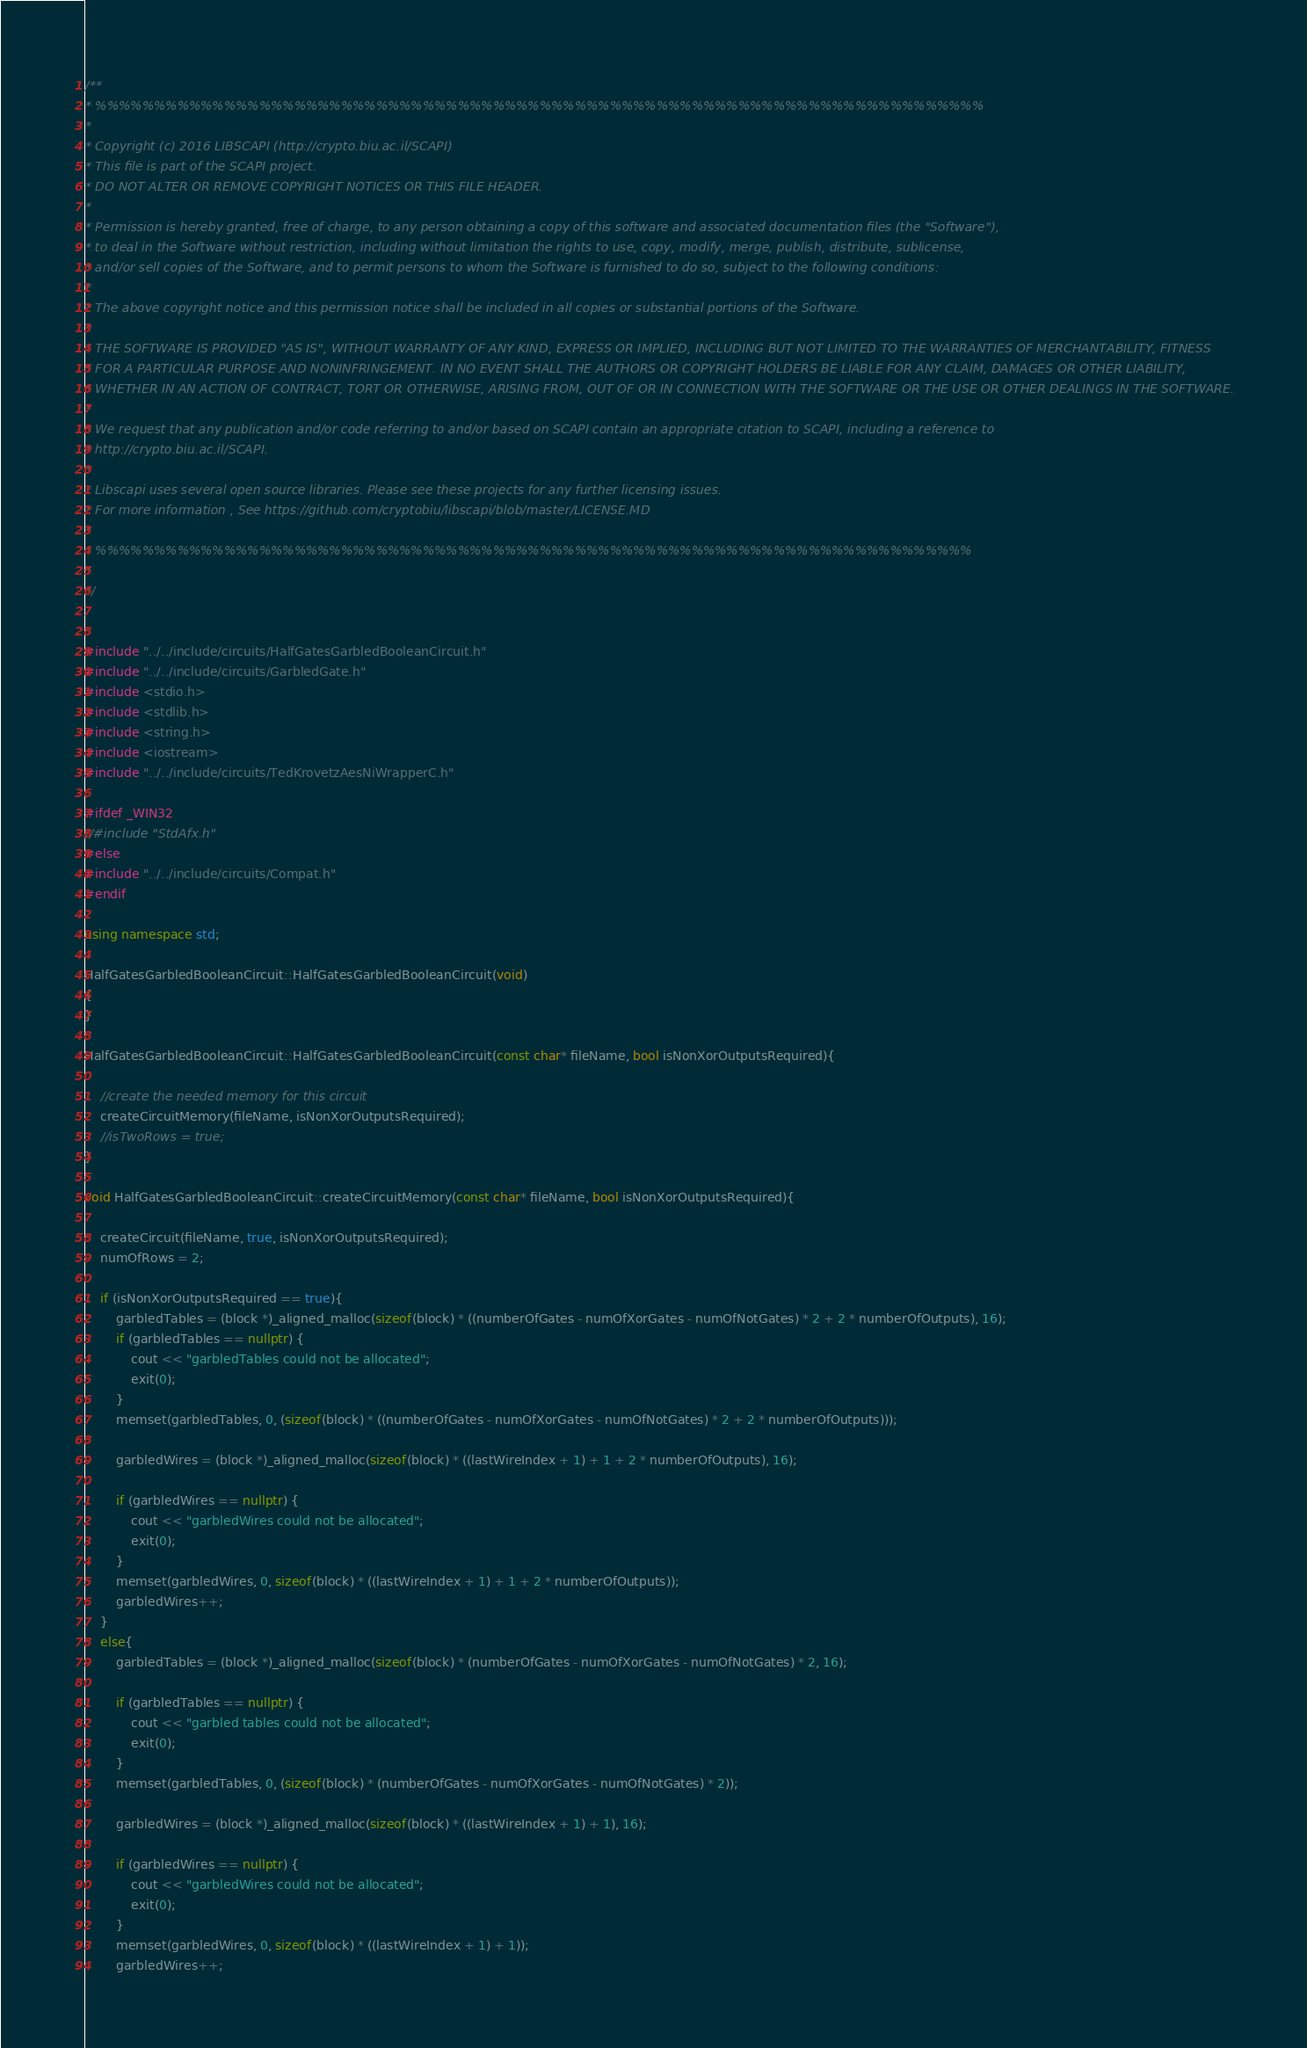<code> <loc_0><loc_0><loc_500><loc_500><_C++_>/**
* %%%%%%%%%%%%%%%%%%%%%%%%%%%%%%%%%%%%%%%%%%%%%%%%%%%%%%%%%%%%%%%%%%%%%%%%%%%%
* 
* Copyright (c) 2016 LIBSCAPI (http://crypto.biu.ac.il/SCAPI)
* This file is part of the SCAPI project.
* DO NOT ALTER OR REMOVE COPYRIGHT NOTICES OR THIS FILE HEADER.
* 
* Permission is hereby granted, free of charge, to any person obtaining a copy of this software and associated documentation files (the "Software"),
* to deal in the Software without restriction, including without limitation the rights to use, copy, modify, merge, publish, distribute, sublicense, 
* and/or sell copies of the Software, and to permit persons to whom the Software is furnished to do so, subject to the following conditions:
* 
* The above copyright notice and this permission notice shall be included in all copies or substantial portions of the Software.
* 
* THE SOFTWARE IS PROVIDED "AS IS", WITHOUT WARRANTY OF ANY KIND, EXPRESS OR IMPLIED, INCLUDING BUT NOT LIMITED TO THE WARRANTIES OF MERCHANTABILITY, FITNESS
* FOR A PARTICULAR PURPOSE AND NONINFRINGEMENT. IN NO EVENT SHALL THE AUTHORS OR COPYRIGHT HOLDERS BE LIABLE FOR ANY CLAIM, DAMAGES OR OTHER LIABILITY,
* WHETHER IN AN ACTION OF CONTRACT, TORT OR OTHERWISE, ARISING FROM, OUT OF OR IN CONNECTION WITH THE SOFTWARE OR THE USE OR OTHER DEALINGS IN THE SOFTWARE.
* 
* We request that any publication and/or code referring to and/or based on SCAPI contain an appropriate citation to SCAPI, including a reference to
* http://crypto.biu.ac.il/SCAPI.
* 
* Libscapi uses several open source libraries. Please see these projects for any further licensing issues.
* For more information , See https://github.com/cryptobiu/libscapi/blob/master/LICENSE.MD
*
* %%%%%%%%%%%%%%%%%%%%%%%%%%%%%%%%%%%%%%%%%%%%%%%%%%%%%%%%%%%%%%%%%%%%%%%%%%%
* 
*/


#include "../../include/circuits/HalfGatesGarbledBooleanCircuit.h"
#include "../../include/circuits/GarbledGate.h"
#include <stdio.h>
#include <stdlib.h>
#include <string.h>
#include <iostream>
#include "../../include/circuits/TedKrovetzAesNiWrapperC.h"

#ifdef _WIN32
//#include "StdAfx.h"
#else
#include "../../include/circuits/Compat.h"
#endif

using namespace std;

HalfGatesGarbledBooleanCircuit::HalfGatesGarbledBooleanCircuit(void)
{
}

HalfGatesGarbledBooleanCircuit::HalfGatesGarbledBooleanCircuit(const char* fileName, bool isNonXorOutputsRequired){

	//create the needed memory for this circuit
	createCircuitMemory(fileName, isNonXorOutputsRequired);
	//isTwoRows = true;
}

void HalfGatesGarbledBooleanCircuit::createCircuitMemory(const char* fileName, bool isNonXorOutputsRequired){

	createCircuit(fileName, true, isNonXorOutputsRequired);
	numOfRows = 2;

	if (isNonXorOutputsRequired == true){
		garbledTables = (block *)_aligned_malloc(sizeof(block) * ((numberOfGates - numOfXorGates - numOfNotGates) * 2 + 2 * numberOfOutputs), 16);
		if (garbledTables == nullptr) {
			cout << "garbledTables could not be allocated";
			exit(0);
		}
		memset(garbledTables, 0, (sizeof(block) * ((numberOfGates - numOfXorGates - numOfNotGates) * 2 + 2 * numberOfOutputs)));

        garbledWires = (block *)_aligned_malloc(sizeof(block) * ((lastWireIndex + 1) + 1 + 2 * numberOfOutputs), 16);

		if (garbledWires == nullptr) {
			cout << "garbledWires could not be allocated";
			exit(0);
		}
		memset(garbledWires, 0, sizeof(block) * ((lastWireIndex + 1) + 1 + 2 * numberOfOutputs));
		garbledWires++;
	}
	else{
		garbledTables = (block *)_aligned_malloc(sizeof(block) * (numberOfGates - numOfXorGates - numOfNotGates) * 2, 16);

		if (garbledTables == nullptr) {
			cout << "garbled tables could not be allocated";
			exit(0);
		}
		memset(garbledTables, 0, (sizeof(block) * (numberOfGates - numOfXorGates - numOfNotGates) * 2));

		garbledWires = (block *)_aligned_malloc(sizeof(block) * ((lastWireIndex + 1) + 1), 16);

		if (garbledWires == nullptr) {
			cout << "garbledWires could not be allocated";
			exit(0);
		}
		memset(garbledWires, 0, sizeof(block) * ((lastWireIndex + 1) + 1));
		garbledWires++;</code> 